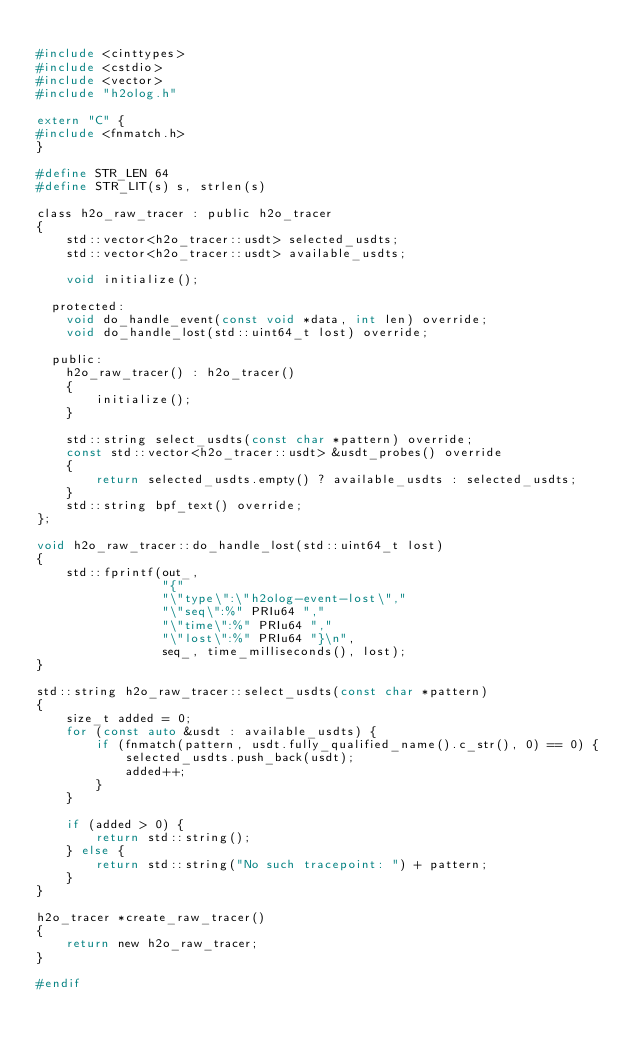<code> <loc_0><loc_0><loc_500><loc_500><_C_>
#include <cinttypes>
#include <cstdio>
#include <vector>
#include "h2olog.h"

extern "C" {
#include <fnmatch.h>
}

#define STR_LEN 64
#define STR_LIT(s) s, strlen(s)

class h2o_raw_tracer : public h2o_tracer
{
    std::vector<h2o_tracer::usdt> selected_usdts;
    std::vector<h2o_tracer::usdt> available_usdts;

    void initialize();

  protected:
    void do_handle_event(const void *data, int len) override;
    void do_handle_lost(std::uint64_t lost) override;

  public:
    h2o_raw_tracer() : h2o_tracer()
    {
        initialize();
    }

    std::string select_usdts(const char *pattern) override;
    const std::vector<h2o_tracer::usdt> &usdt_probes() override
    {
        return selected_usdts.empty() ? available_usdts : selected_usdts;
    }
    std::string bpf_text() override;
};

void h2o_raw_tracer::do_handle_lost(std::uint64_t lost)
{
    std::fprintf(out_,
                 "{"
                 "\"type\":\"h2olog-event-lost\","
                 "\"seq\":%" PRIu64 ","
                 "\"time\":%" PRIu64 ","
                 "\"lost\":%" PRIu64 "}\n",
                 seq_, time_milliseconds(), lost);
}

std::string h2o_raw_tracer::select_usdts(const char *pattern)
{
    size_t added = 0;
    for (const auto &usdt : available_usdts) {
        if (fnmatch(pattern, usdt.fully_qualified_name().c_str(), 0) == 0) {
            selected_usdts.push_back(usdt);
            added++;
        }
    }

    if (added > 0) {
        return std::string();
    } else {
        return std::string("No such tracepoint: ") + pattern;
    }
}

h2o_tracer *create_raw_tracer()
{
    return new h2o_raw_tracer;
}

#endif
</code> 